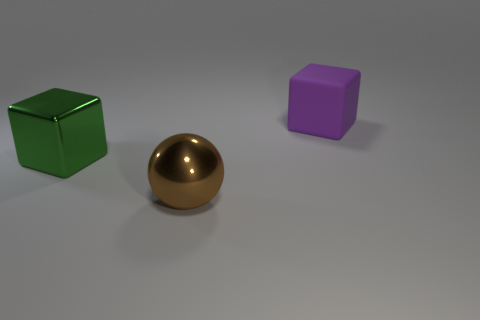Add 3 yellow cubes. How many objects exist? 6 Subtract all spheres. How many objects are left? 2 Subtract all blocks. Subtract all green objects. How many objects are left? 0 Add 1 large rubber cubes. How many large rubber cubes are left? 2 Add 3 big balls. How many big balls exist? 4 Subtract 1 green blocks. How many objects are left? 2 